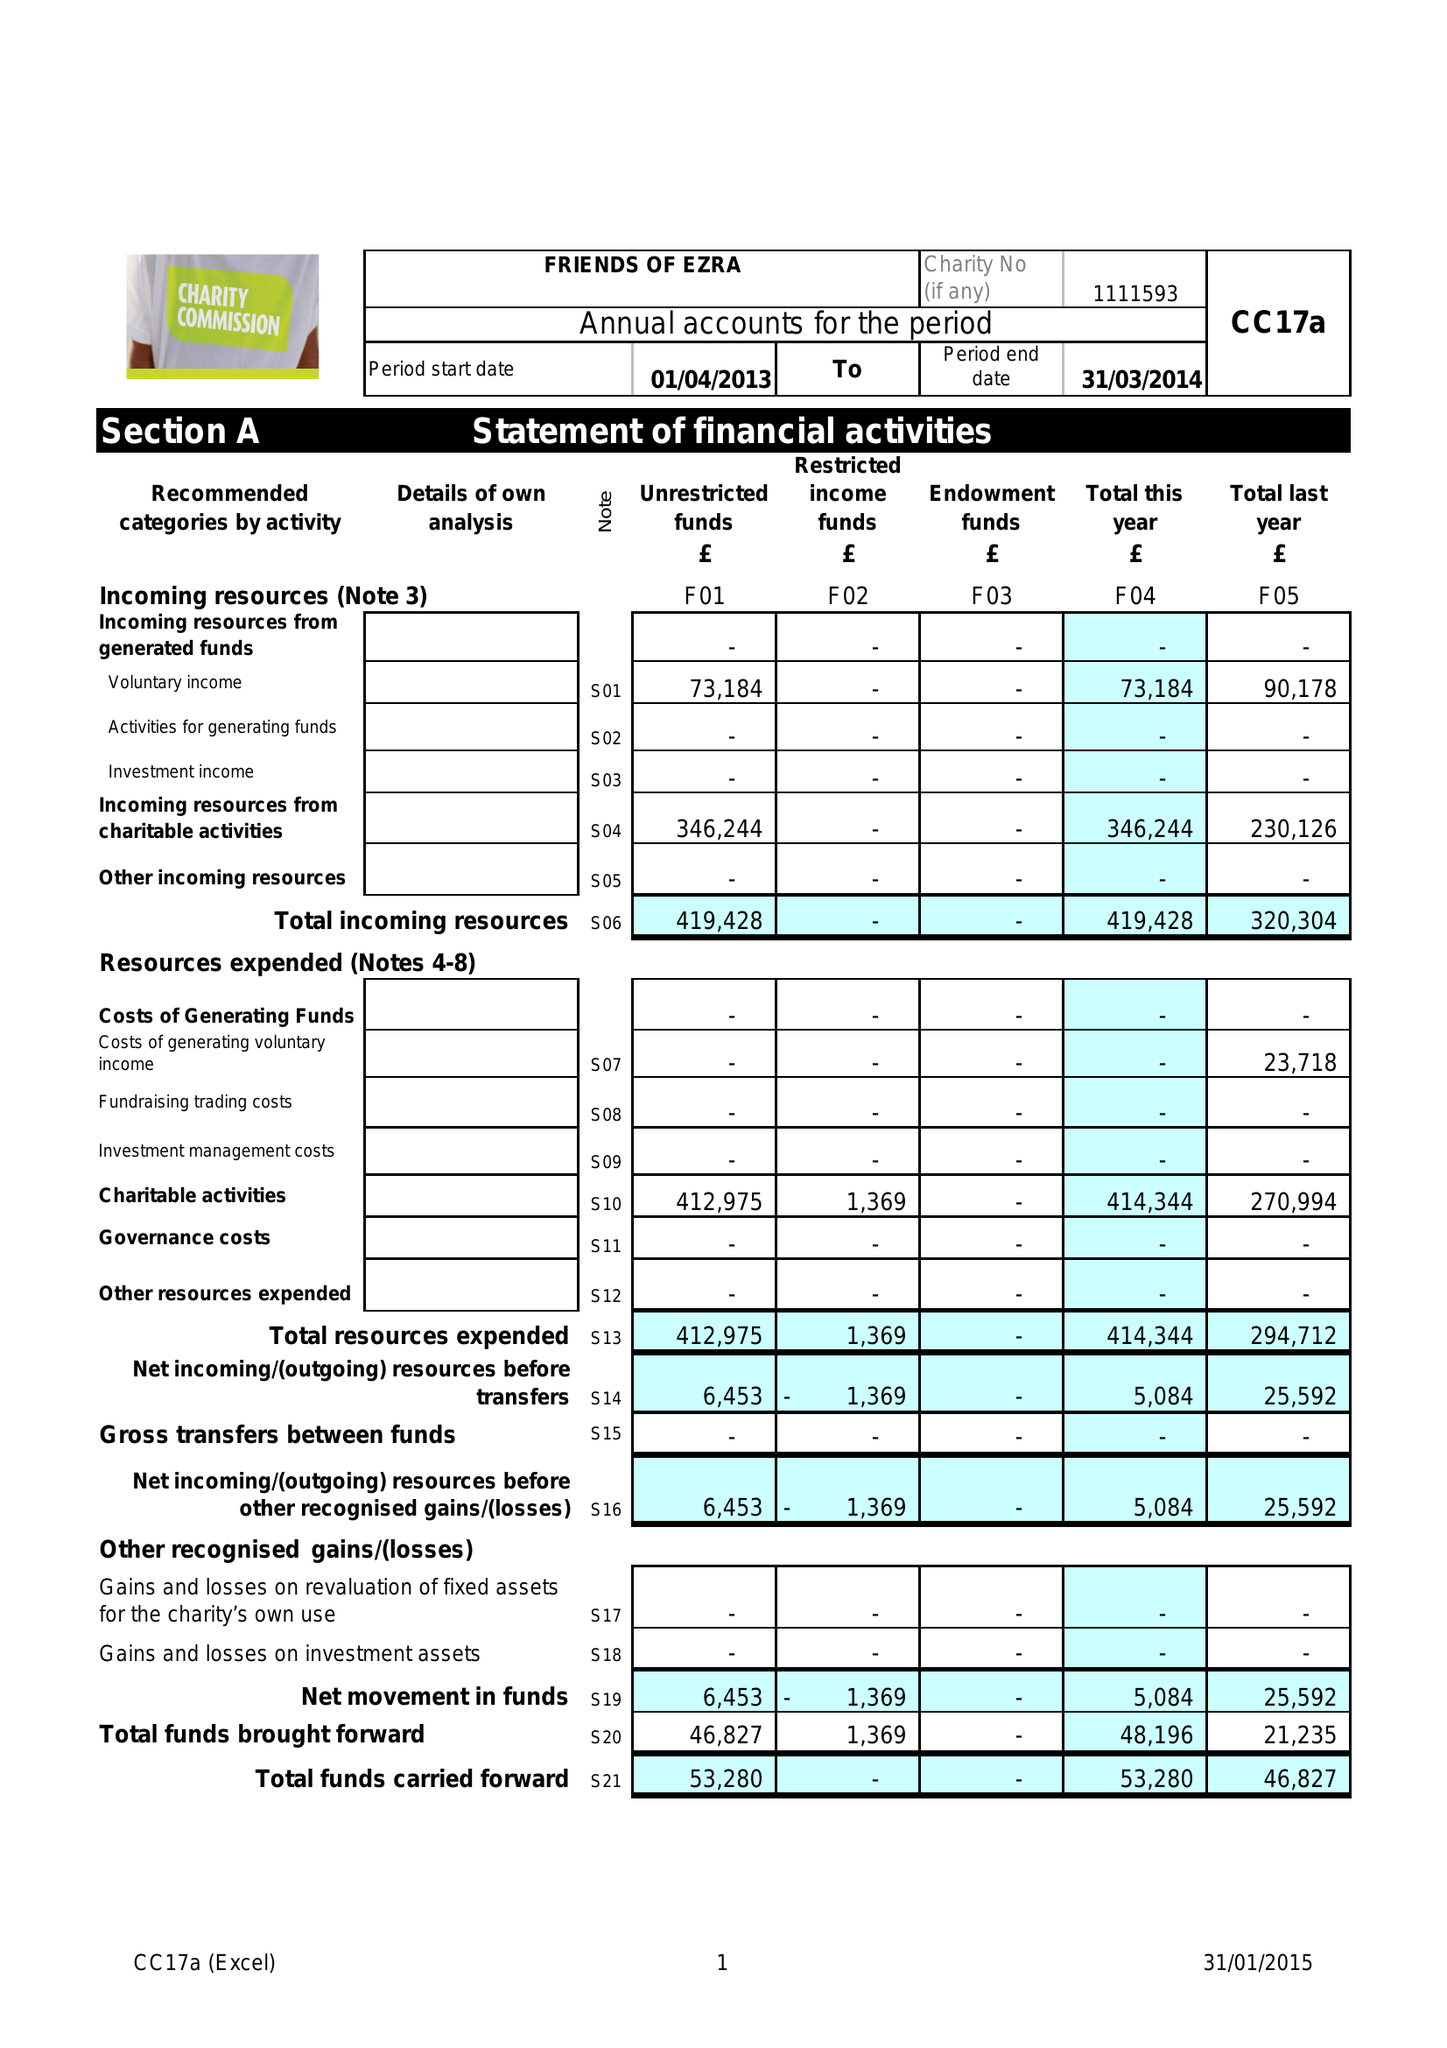What is the value for the charity_name?
Answer the question using a single word or phrase. Friends Of Ezra 